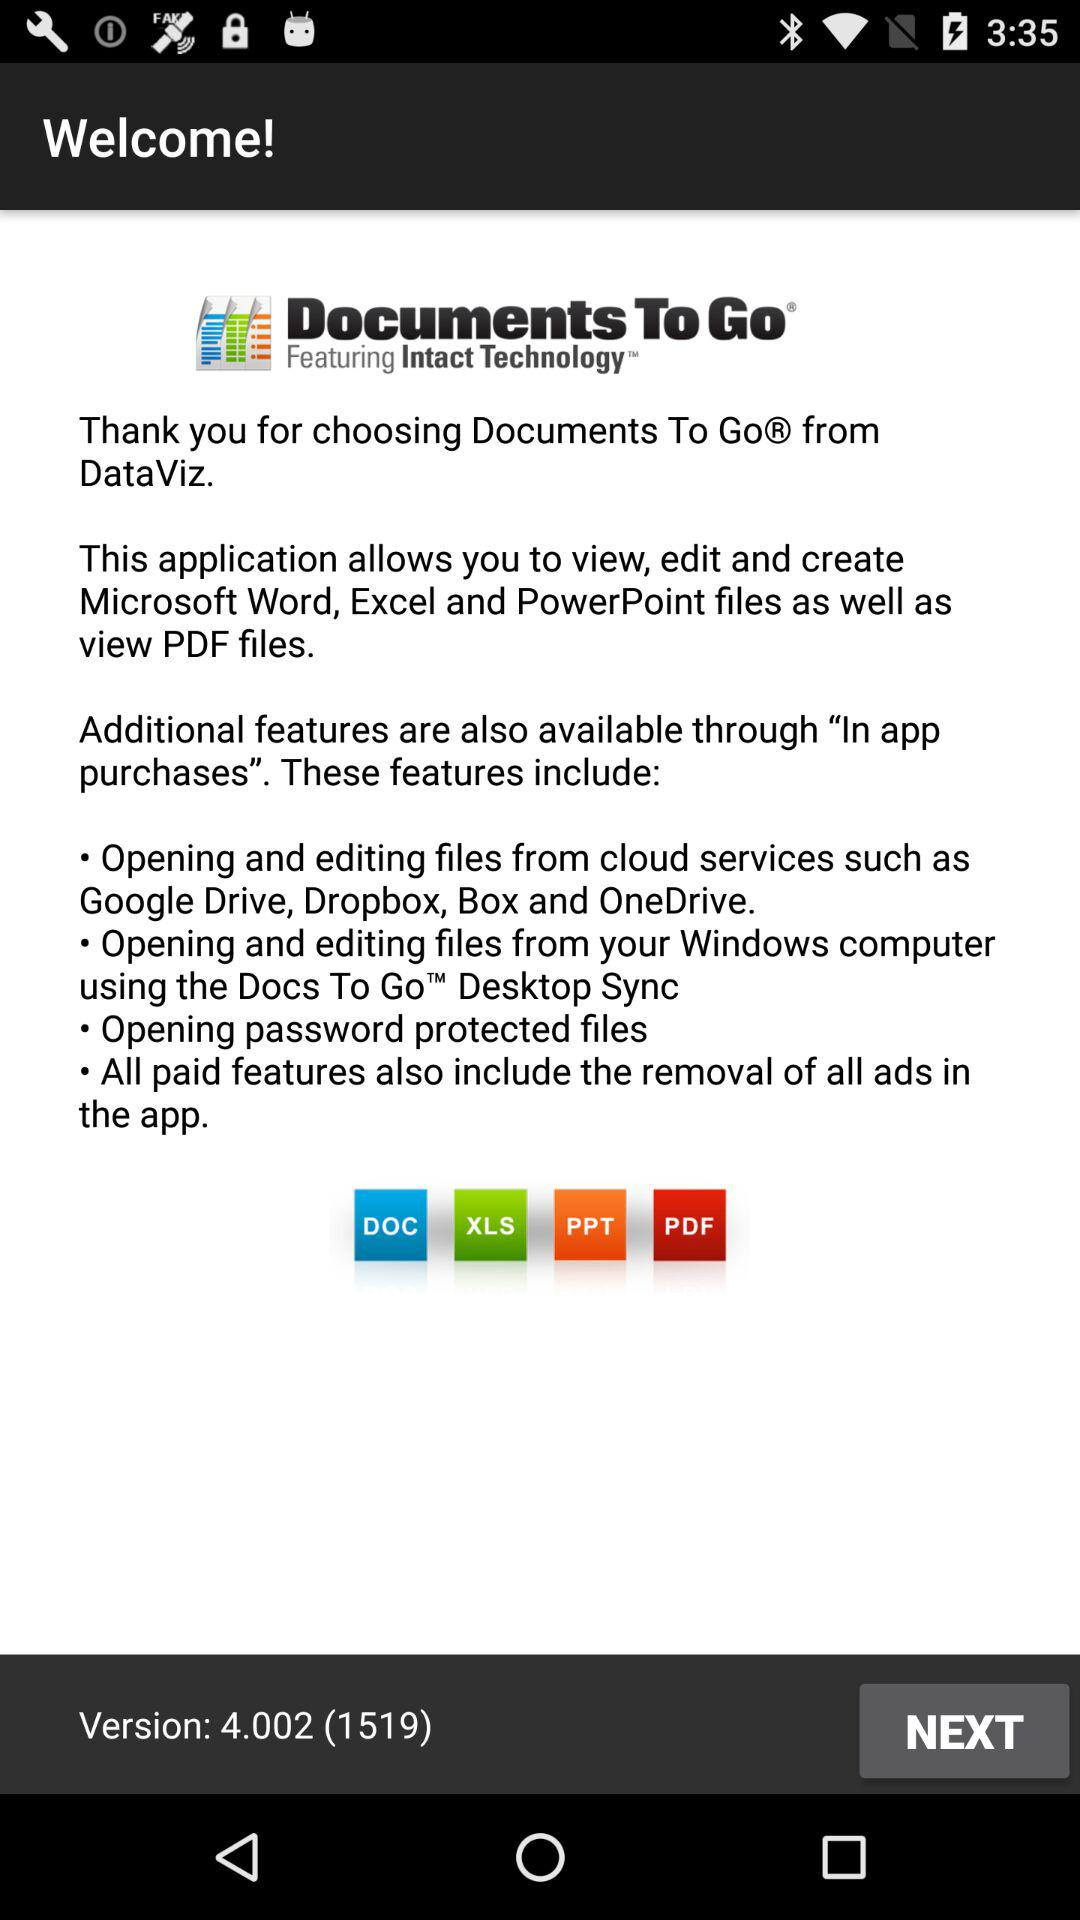How many features are available through in-app purchases?
Answer the question using a single word or phrase. 4 